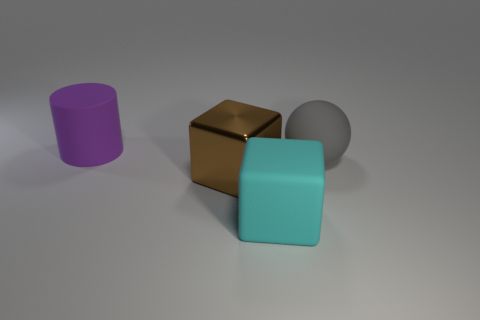How many matte objects are cubes or large gray objects?
Offer a terse response. 2. What is the gray object made of?
Offer a terse response. Rubber. There is a brown object; how many shiny blocks are behind it?
Your answer should be compact. 0. Are the big object that is behind the rubber sphere and the large cyan object made of the same material?
Offer a terse response. Yes. What number of other large things are the same shape as the purple object?
Make the answer very short. 0. How many large things are yellow rubber cylinders or gray spheres?
Your response must be concise. 1. There is a large rubber thing right of the cyan object; is its color the same as the large rubber cube?
Give a very brief answer. No. There is a large rubber thing that is behind the big sphere; is it the same color as the matte thing that is in front of the brown block?
Keep it short and to the point. No. Are there any cyan spheres made of the same material as the big purple cylinder?
Give a very brief answer. No. How many brown things are either big shiny cubes or large rubber cylinders?
Provide a succinct answer. 1. 